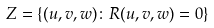Convert formula to latex. <formula><loc_0><loc_0><loc_500><loc_500>Z = \left \{ ( u , v , w ) \colon R ( u , v , w ) = 0 \right \}</formula> 